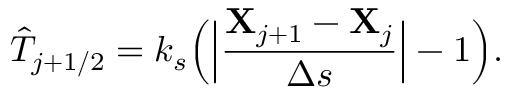Convert formula to latex. <formula><loc_0><loc_0><loc_500><loc_500>\hat { T } _ { j + 1 / 2 } = k _ { s } \left ( \left | \frac { { X } _ { j + 1 } - { X } _ { j } } { \Delta s } \right | - 1 \right ) .</formula> 